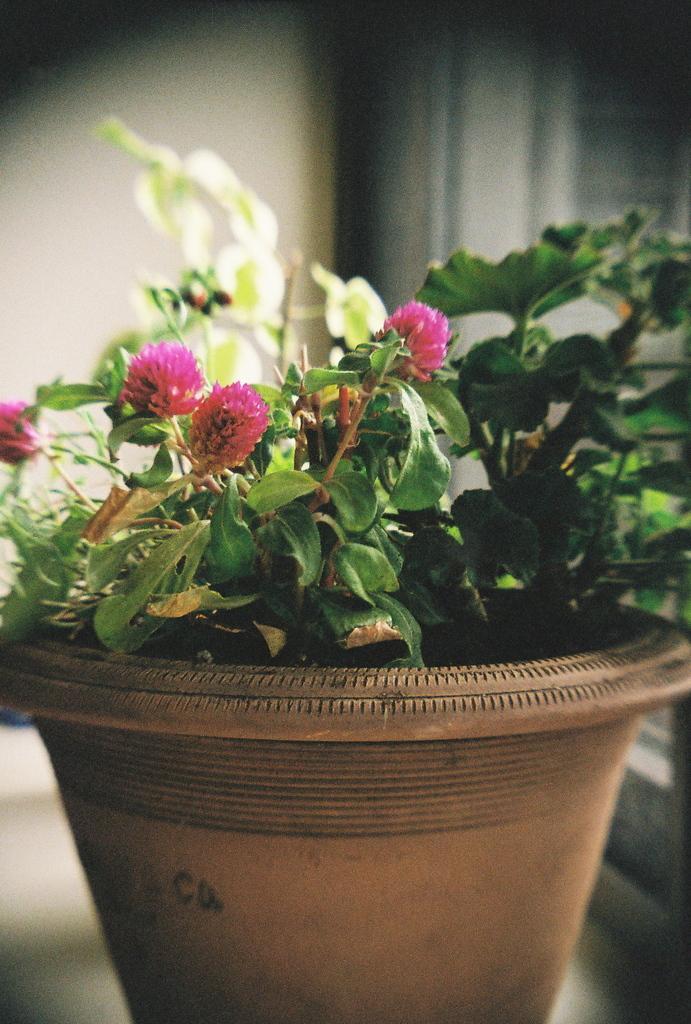Can you describe this image briefly? In this image we can see plants with flowers in the pot on a platform. In the background the image is not clear to describe. 